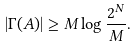Convert formula to latex. <formula><loc_0><loc_0><loc_500><loc_500>| \Gamma ( A ) | \geq M \log \frac { 2 ^ { N } } { M } .</formula> 